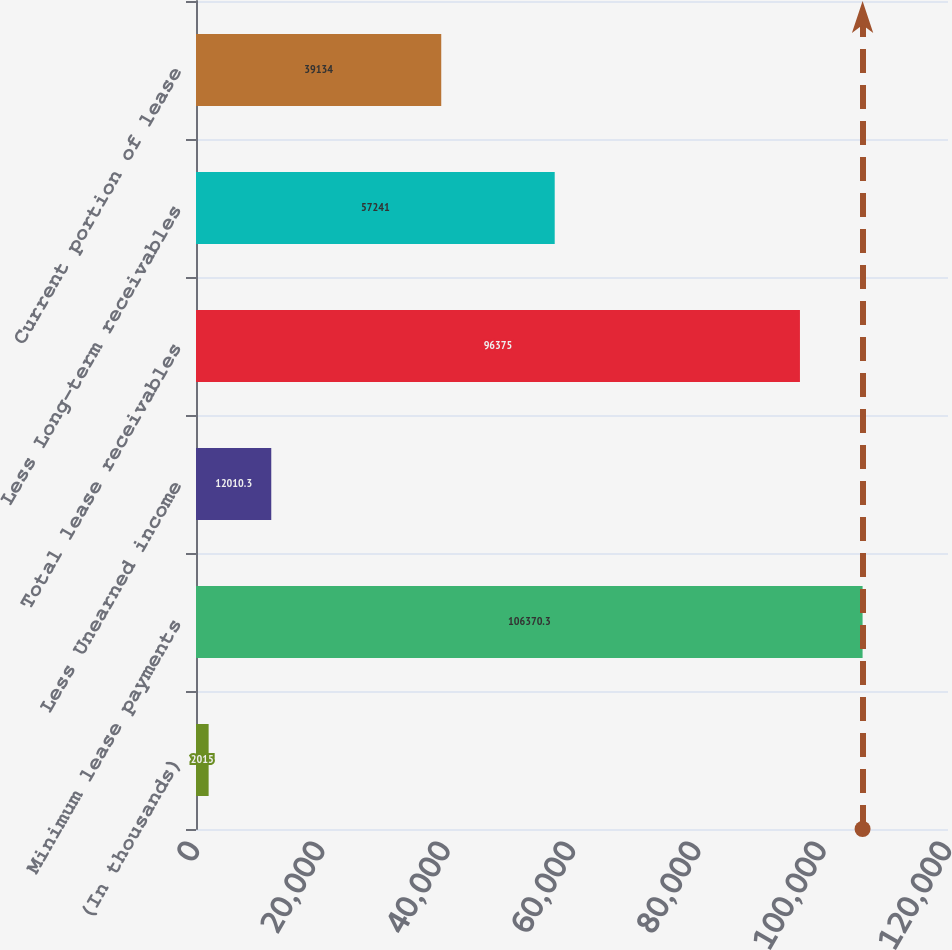<chart> <loc_0><loc_0><loc_500><loc_500><bar_chart><fcel>(In thousands)<fcel>Minimum lease payments<fcel>Less Unearned income<fcel>Total lease receivables<fcel>Less Long-term receivables<fcel>Current portion of lease<nl><fcel>2015<fcel>106370<fcel>12010.3<fcel>96375<fcel>57241<fcel>39134<nl></chart> 